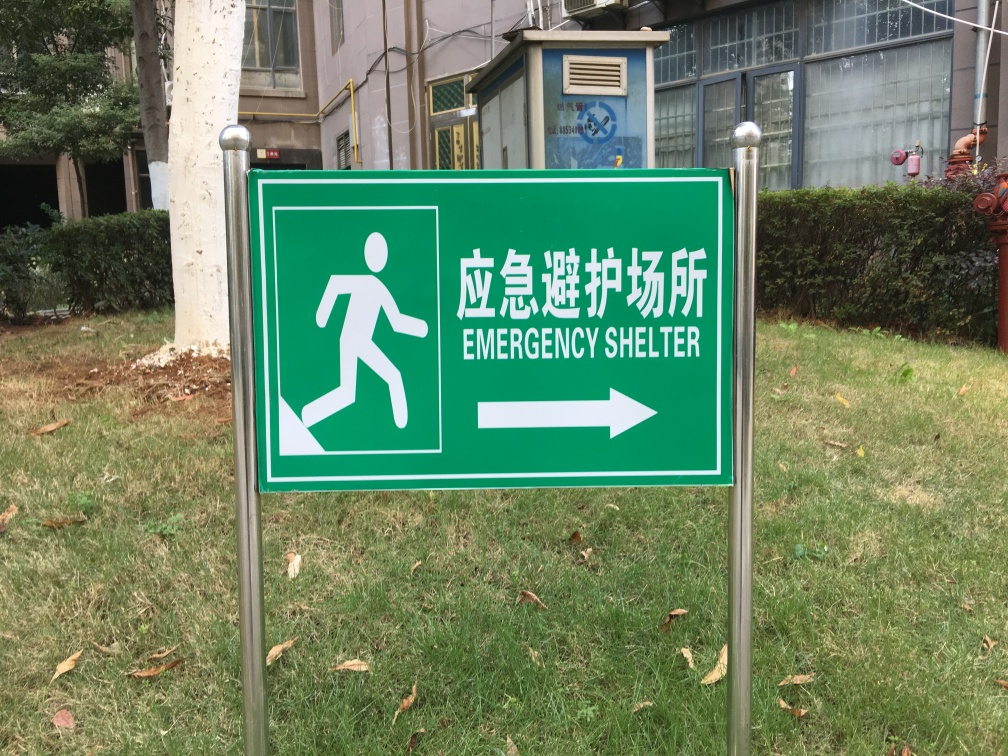What information is conveyed by the sign in this image? The image shows a sign indicating the direction to an emergency shelter. Specifically, the pictogram of a running person and the arrow directs individuals to move towards the right to reach safety. The text is bilingual, with 'Emergency Shelter' written in English and its equivalent in Chinese, catering to a broad audience for clear understanding in an emergency. 